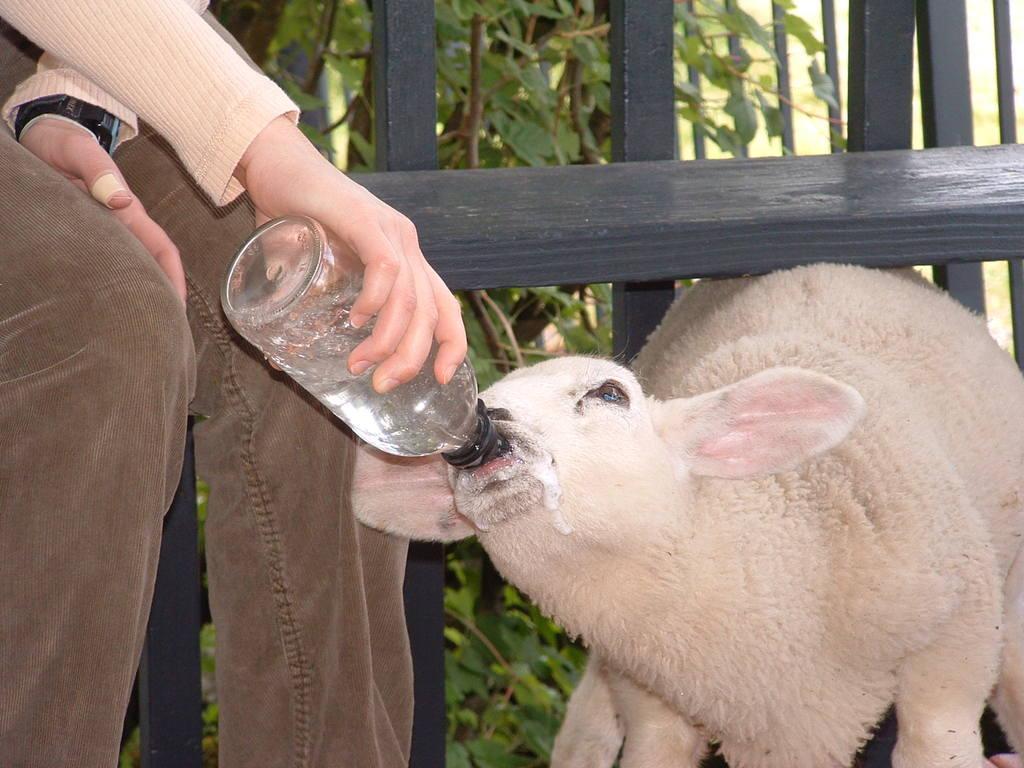Please provide a concise description of this image. A person is feeding an animal with a bottle. He is wearing a watch. In the background there is a wooden fencing and trees. 